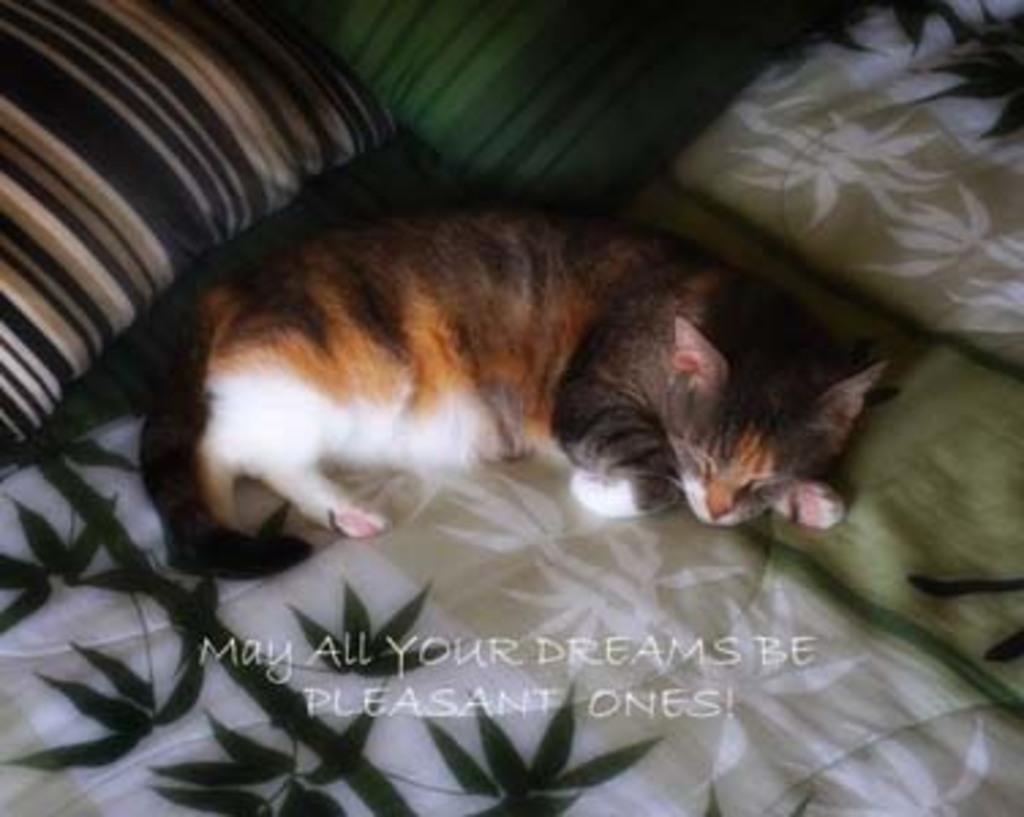What is on the bed in the image? There are pillows on the bed. What type of animal can be seen on the bed? There is a cat on the bed. How many dolls are visible on the window sill in the image? There are no dolls visible on the window sill in the image. 